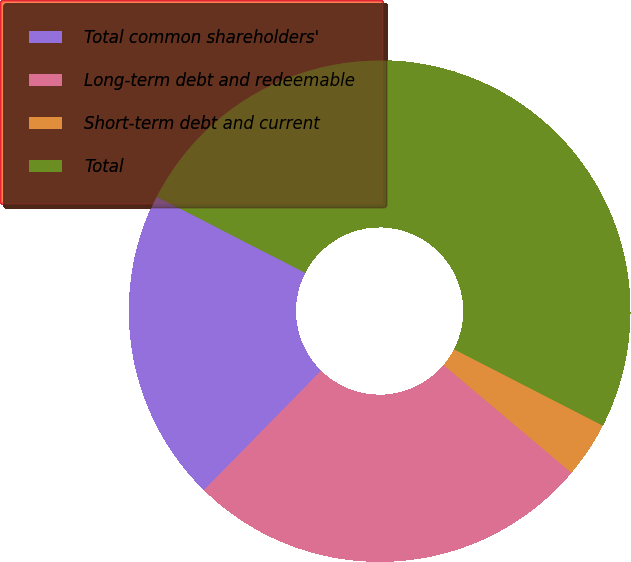<chart> <loc_0><loc_0><loc_500><loc_500><pie_chart><fcel>Total common shareholders'<fcel>Long-term debt and redeemable<fcel>Short-term debt and current<fcel>Total<nl><fcel>20.2%<fcel>26.2%<fcel>3.6%<fcel>50.0%<nl></chart> 